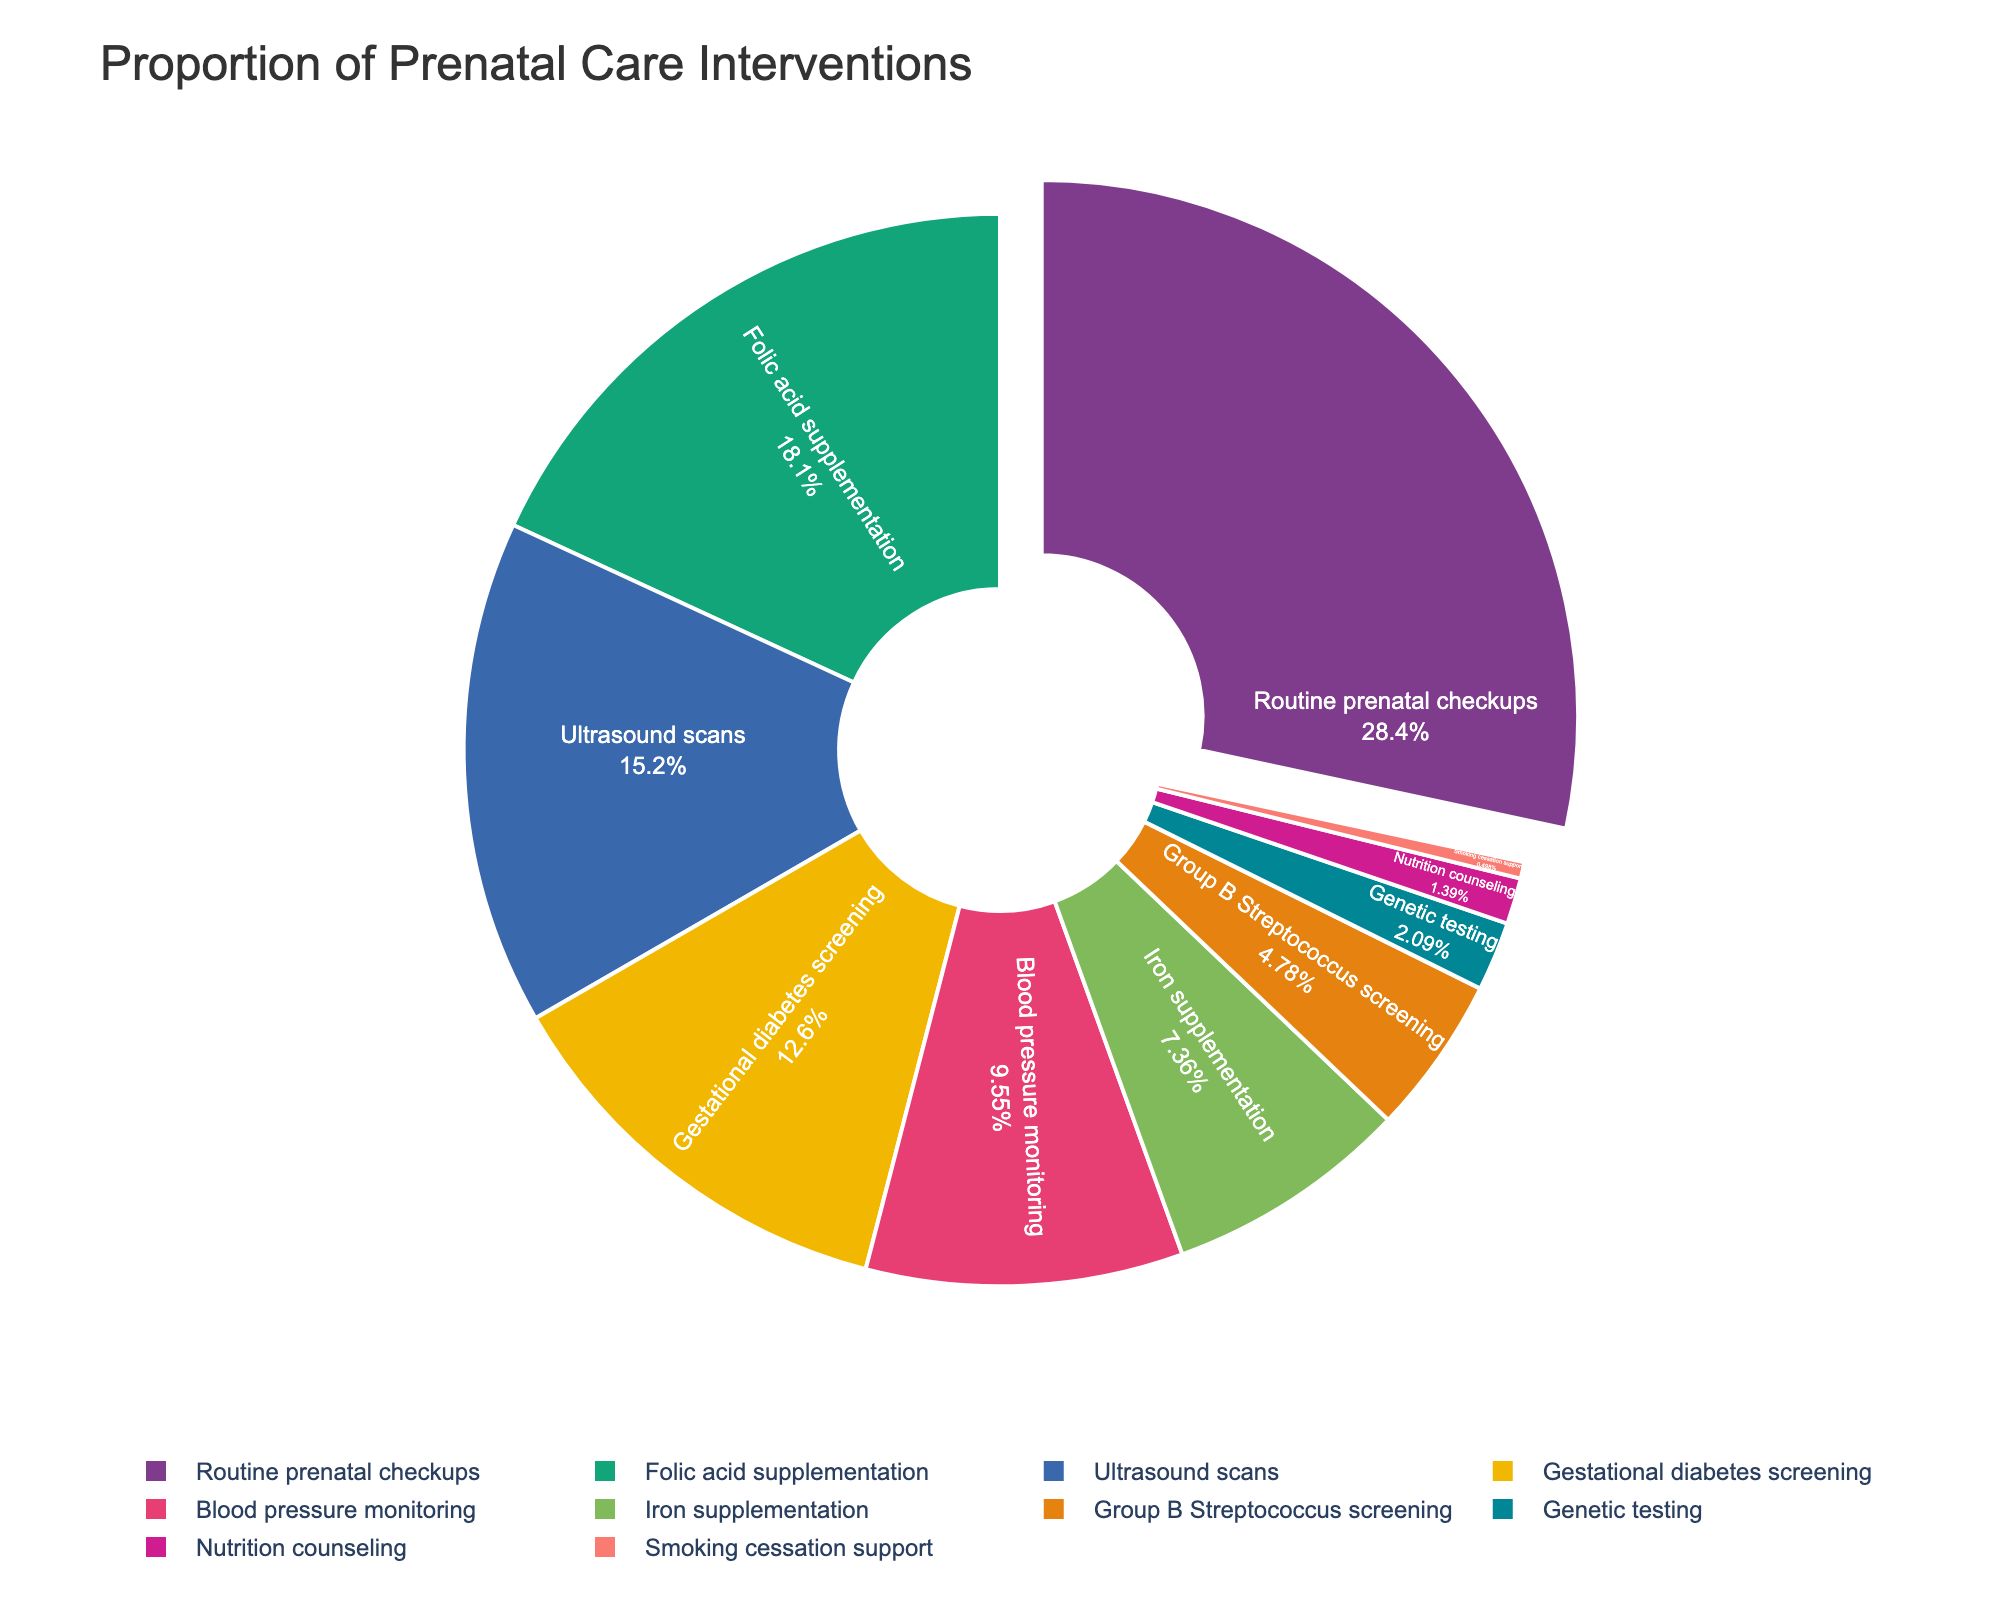What's the intervention with the highest proportion? The intervention with the highest proportion is the one with the largest slice in the pie chart.
Answer: Routine prenatal checkups Which intervention has a higher proportion: Iron supplementation or Blood pressure monitoring? Look at the slices representing Iron supplementation and Blood pressure monitoring, and compare their percentages. Iron supplementation is 7.4%, and Blood pressure monitoring is 9.6%.
Answer: Blood pressure monitoring What is the total percentage of interventions related to supplementation (Folic acid, Iron)? Sum the percentages for Folic acid supplementation (18.2%) and Iron supplementation (7.4%). 18.2 + 7.4 = 25.6.
Answer: 25.6% Which intervention has a smaller proportion: Genetic testing or Smoking cessation support? Look at the slices for Genetic testing and Smoking cessation support, and compare their percentages. Genetic testing is 2.1%, and Smoking cessation support is 0.5%.
Answer: Smoking cessation support How much larger is the proportion of Routine prenatal checkups compared to Ultrasound scans? Subtract the percentage of Ultrasound scans (15.3%) from the percentage of Routine prenatal checkups (28.5%). 28.5 - 15.3 = 13.2.
Answer: 13.2% What is the combined percentage of Group B Streptococcus screening and Gestational diabetes screening? Sum the percentages for Group B Streptococcus screening (4.8%) and Gestational diabetes screening (12.7%). 4.8 + 12.7 = 17.5.
Answer: 17.5% Which interventions make up less than 5% each of the total interventions? Identify the slices with percentages less than 5%. These are Group B Streptococcus screening (4.8%), Genetic testing (2.1%), Nutrition counseling (1.4%), and Smoking cessation support (0.5%).
Answer: Group B Streptococcus screening, Genetic testing, Nutrition counseling, Smoking cessation support Is the proportion of Folic acid supplementation greater or less than double the proportion of Genetic testing? Double the percentage of Genetic testing (2.1% x 2 = 4.2%) and compare it to the percentage of Folic acid supplementation (18.2%). Since 18.2 > 4.2, it is greater.
Answer: Greater What is the approximate percentage of interventions that are not Routine prenatal checkups? Subtract the percentage of Routine prenatal checkups (28.5%) from 100%. 100 - 28.5 = 71.5.
Answer: 71.5% How does the proportion of Blood pressure monitoring compare to the average proportion of all ten interventions? First, calculate the average proportion by summing all percentages (28.5 + 18.2 + 12.7 + 15.3 + 9.6 + 7.4 + 4.8 + 2.1 + 1.4 + 0.5 = 100.5) and dividing by 10. The average is 100.5 / 10 = 10.05%. Then, compare Blood pressure monitoring (9.6%) to 10.05%. 9.6 < 10.05.
Answer: Less 